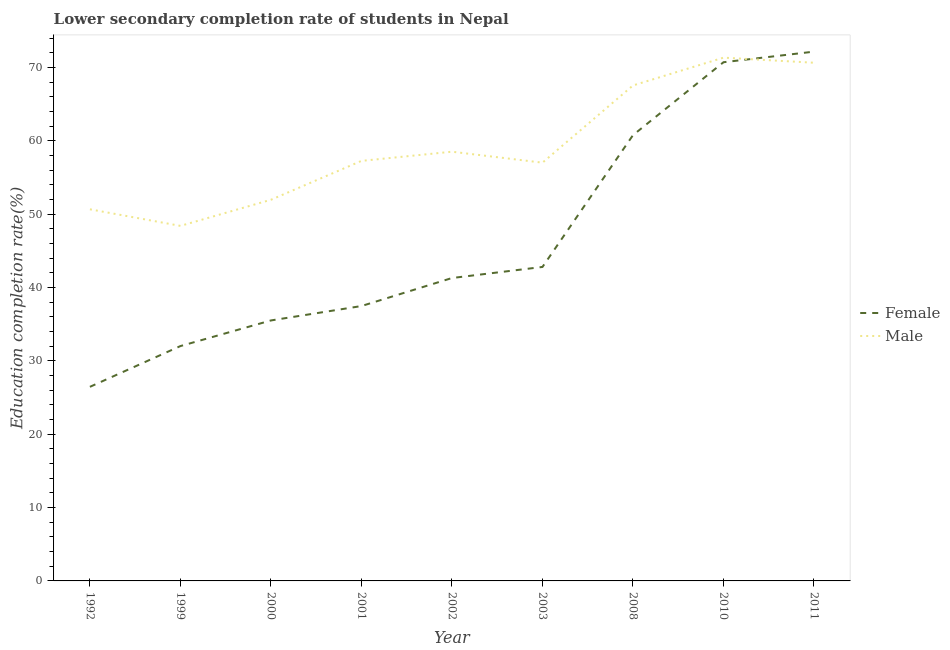Does the line corresponding to education completion rate of male students intersect with the line corresponding to education completion rate of female students?
Give a very brief answer. Yes. What is the education completion rate of female students in 1992?
Keep it short and to the point. 26.46. Across all years, what is the maximum education completion rate of female students?
Make the answer very short. 72.17. Across all years, what is the minimum education completion rate of female students?
Your response must be concise. 26.46. What is the total education completion rate of female students in the graph?
Your answer should be compact. 419.26. What is the difference between the education completion rate of male students in 1992 and that in 2010?
Give a very brief answer. -20.68. What is the difference between the education completion rate of male students in 2003 and the education completion rate of female students in 2002?
Make the answer very short. 15.73. What is the average education completion rate of female students per year?
Offer a very short reply. 46.58. In the year 2000, what is the difference between the education completion rate of female students and education completion rate of male students?
Your answer should be very brief. -16.45. What is the ratio of the education completion rate of male students in 2001 to that in 2011?
Your response must be concise. 0.81. Is the difference between the education completion rate of female students in 1999 and 2002 greater than the difference between the education completion rate of male students in 1999 and 2002?
Ensure brevity in your answer.  Yes. What is the difference between the highest and the second highest education completion rate of male students?
Your answer should be very brief. 0.69. What is the difference between the highest and the lowest education completion rate of male students?
Provide a succinct answer. 22.94. Is the sum of the education completion rate of female students in 2008 and 2011 greater than the maximum education completion rate of male students across all years?
Provide a succinct answer. Yes. Is the education completion rate of male students strictly less than the education completion rate of female students over the years?
Make the answer very short. No. Are the values on the major ticks of Y-axis written in scientific E-notation?
Your answer should be compact. No. Does the graph contain grids?
Give a very brief answer. No. Where does the legend appear in the graph?
Offer a terse response. Center right. What is the title of the graph?
Your answer should be very brief. Lower secondary completion rate of students in Nepal. What is the label or title of the X-axis?
Provide a succinct answer. Year. What is the label or title of the Y-axis?
Your response must be concise. Education completion rate(%). What is the Education completion rate(%) in Female in 1992?
Provide a succinct answer. 26.46. What is the Education completion rate(%) in Male in 1992?
Make the answer very short. 50.67. What is the Education completion rate(%) in Female in 1999?
Provide a short and direct response. 32.02. What is the Education completion rate(%) of Male in 1999?
Make the answer very short. 48.41. What is the Education completion rate(%) of Female in 2000?
Your answer should be compact. 35.52. What is the Education completion rate(%) in Male in 2000?
Keep it short and to the point. 51.97. What is the Education completion rate(%) in Female in 2001?
Provide a succinct answer. 37.48. What is the Education completion rate(%) of Male in 2001?
Make the answer very short. 57.27. What is the Education completion rate(%) of Female in 2002?
Offer a very short reply. 41.3. What is the Education completion rate(%) of Male in 2002?
Offer a very short reply. 58.52. What is the Education completion rate(%) of Female in 2003?
Provide a succinct answer. 42.81. What is the Education completion rate(%) in Male in 2003?
Keep it short and to the point. 57.03. What is the Education completion rate(%) of Female in 2008?
Provide a short and direct response. 60.78. What is the Education completion rate(%) of Male in 2008?
Offer a terse response. 67.56. What is the Education completion rate(%) in Female in 2010?
Provide a short and direct response. 70.72. What is the Education completion rate(%) in Male in 2010?
Provide a succinct answer. 71.35. What is the Education completion rate(%) in Female in 2011?
Keep it short and to the point. 72.17. What is the Education completion rate(%) in Male in 2011?
Keep it short and to the point. 70.65. Across all years, what is the maximum Education completion rate(%) in Female?
Keep it short and to the point. 72.17. Across all years, what is the maximum Education completion rate(%) in Male?
Your answer should be compact. 71.35. Across all years, what is the minimum Education completion rate(%) in Female?
Provide a succinct answer. 26.46. Across all years, what is the minimum Education completion rate(%) of Male?
Offer a terse response. 48.41. What is the total Education completion rate(%) in Female in the graph?
Offer a very short reply. 419.26. What is the total Education completion rate(%) of Male in the graph?
Offer a very short reply. 533.43. What is the difference between the Education completion rate(%) in Female in 1992 and that in 1999?
Give a very brief answer. -5.56. What is the difference between the Education completion rate(%) in Male in 1992 and that in 1999?
Your answer should be very brief. 2.26. What is the difference between the Education completion rate(%) in Female in 1992 and that in 2000?
Make the answer very short. -9.05. What is the difference between the Education completion rate(%) of Female in 1992 and that in 2001?
Offer a very short reply. -11.02. What is the difference between the Education completion rate(%) of Male in 1992 and that in 2001?
Ensure brevity in your answer.  -6.6. What is the difference between the Education completion rate(%) of Female in 1992 and that in 2002?
Your response must be concise. -14.84. What is the difference between the Education completion rate(%) of Male in 1992 and that in 2002?
Provide a succinct answer. -7.85. What is the difference between the Education completion rate(%) in Female in 1992 and that in 2003?
Your answer should be compact. -16.35. What is the difference between the Education completion rate(%) of Male in 1992 and that in 2003?
Your response must be concise. -6.36. What is the difference between the Education completion rate(%) of Female in 1992 and that in 2008?
Make the answer very short. -34.32. What is the difference between the Education completion rate(%) in Male in 1992 and that in 2008?
Make the answer very short. -16.89. What is the difference between the Education completion rate(%) in Female in 1992 and that in 2010?
Your answer should be compact. -44.26. What is the difference between the Education completion rate(%) in Male in 1992 and that in 2010?
Your response must be concise. -20.68. What is the difference between the Education completion rate(%) of Female in 1992 and that in 2011?
Provide a succinct answer. -45.7. What is the difference between the Education completion rate(%) in Male in 1992 and that in 2011?
Your answer should be very brief. -19.98. What is the difference between the Education completion rate(%) in Female in 1999 and that in 2000?
Give a very brief answer. -3.49. What is the difference between the Education completion rate(%) of Male in 1999 and that in 2000?
Your answer should be very brief. -3.56. What is the difference between the Education completion rate(%) of Female in 1999 and that in 2001?
Provide a succinct answer. -5.46. What is the difference between the Education completion rate(%) of Male in 1999 and that in 2001?
Keep it short and to the point. -8.86. What is the difference between the Education completion rate(%) in Female in 1999 and that in 2002?
Offer a very short reply. -9.28. What is the difference between the Education completion rate(%) of Male in 1999 and that in 2002?
Your response must be concise. -10.11. What is the difference between the Education completion rate(%) in Female in 1999 and that in 2003?
Offer a terse response. -10.79. What is the difference between the Education completion rate(%) of Male in 1999 and that in 2003?
Provide a short and direct response. -8.62. What is the difference between the Education completion rate(%) of Female in 1999 and that in 2008?
Ensure brevity in your answer.  -28.76. What is the difference between the Education completion rate(%) in Male in 1999 and that in 2008?
Your answer should be compact. -19.15. What is the difference between the Education completion rate(%) of Female in 1999 and that in 2010?
Keep it short and to the point. -38.7. What is the difference between the Education completion rate(%) in Male in 1999 and that in 2010?
Provide a short and direct response. -22.94. What is the difference between the Education completion rate(%) in Female in 1999 and that in 2011?
Make the answer very short. -40.15. What is the difference between the Education completion rate(%) in Male in 1999 and that in 2011?
Make the answer very short. -22.24. What is the difference between the Education completion rate(%) in Female in 2000 and that in 2001?
Your answer should be very brief. -1.96. What is the difference between the Education completion rate(%) in Male in 2000 and that in 2001?
Keep it short and to the point. -5.3. What is the difference between the Education completion rate(%) of Female in 2000 and that in 2002?
Ensure brevity in your answer.  -5.78. What is the difference between the Education completion rate(%) of Male in 2000 and that in 2002?
Provide a succinct answer. -6.55. What is the difference between the Education completion rate(%) in Female in 2000 and that in 2003?
Keep it short and to the point. -7.29. What is the difference between the Education completion rate(%) in Male in 2000 and that in 2003?
Give a very brief answer. -5.06. What is the difference between the Education completion rate(%) in Female in 2000 and that in 2008?
Give a very brief answer. -25.27. What is the difference between the Education completion rate(%) of Male in 2000 and that in 2008?
Your answer should be compact. -15.59. What is the difference between the Education completion rate(%) in Female in 2000 and that in 2010?
Offer a terse response. -35.21. What is the difference between the Education completion rate(%) in Male in 2000 and that in 2010?
Your answer should be compact. -19.38. What is the difference between the Education completion rate(%) in Female in 2000 and that in 2011?
Your answer should be very brief. -36.65. What is the difference between the Education completion rate(%) of Male in 2000 and that in 2011?
Keep it short and to the point. -18.68. What is the difference between the Education completion rate(%) in Female in 2001 and that in 2002?
Offer a very short reply. -3.82. What is the difference between the Education completion rate(%) of Male in 2001 and that in 2002?
Your response must be concise. -1.25. What is the difference between the Education completion rate(%) of Female in 2001 and that in 2003?
Offer a very short reply. -5.33. What is the difference between the Education completion rate(%) in Male in 2001 and that in 2003?
Provide a short and direct response. 0.24. What is the difference between the Education completion rate(%) of Female in 2001 and that in 2008?
Provide a short and direct response. -23.3. What is the difference between the Education completion rate(%) in Male in 2001 and that in 2008?
Offer a terse response. -10.29. What is the difference between the Education completion rate(%) in Female in 2001 and that in 2010?
Make the answer very short. -33.24. What is the difference between the Education completion rate(%) of Male in 2001 and that in 2010?
Make the answer very short. -14.08. What is the difference between the Education completion rate(%) of Female in 2001 and that in 2011?
Make the answer very short. -34.69. What is the difference between the Education completion rate(%) of Male in 2001 and that in 2011?
Ensure brevity in your answer.  -13.38. What is the difference between the Education completion rate(%) of Female in 2002 and that in 2003?
Your answer should be compact. -1.51. What is the difference between the Education completion rate(%) in Male in 2002 and that in 2003?
Give a very brief answer. 1.5. What is the difference between the Education completion rate(%) in Female in 2002 and that in 2008?
Offer a terse response. -19.48. What is the difference between the Education completion rate(%) of Male in 2002 and that in 2008?
Your answer should be compact. -9.03. What is the difference between the Education completion rate(%) in Female in 2002 and that in 2010?
Ensure brevity in your answer.  -29.42. What is the difference between the Education completion rate(%) of Male in 2002 and that in 2010?
Provide a succinct answer. -12.82. What is the difference between the Education completion rate(%) of Female in 2002 and that in 2011?
Give a very brief answer. -30.87. What is the difference between the Education completion rate(%) of Male in 2002 and that in 2011?
Your answer should be compact. -12.13. What is the difference between the Education completion rate(%) of Female in 2003 and that in 2008?
Make the answer very short. -17.97. What is the difference between the Education completion rate(%) in Male in 2003 and that in 2008?
Make the answer very short. -10.53. What is the difference between the Education completion rate(%) in Female in 2003 and that in 2010?
Give a very brief answer. -27.91. What is the difference between the Education completion rate(%) of Male in 2003 and that in 2010?
Provide a succinct answer. -14.32. What is the difference between the Education completion rate(%) of Female in 2003 and that in 2011?
Provide a short and direct response. -29.36. What is the difference between the Education completion rate(%) in Male in 2003 and that in 2011?
Give a very brief answer. -13.63. What is the difference between the Education completion rate(%) of Female in 2008 and that in 2010?
Give a very brief answer. -9.94. What is the difference between the Education completion rate(%) of Male in 2008 and that in 2010?
Make the answer very short. -3.79. What is the difference between the Education completion rate(%) in Female in 2008 and that in 2011?
Make the answer very short. -11.39. What is the difference between the Education completion rate(%) in Male in 2008 and that in 2011?
Make the answer very short. -3.1. What is the difference between the Education completion rate(%) in Female in 2010 and that in 2011?
Provide a short and direct response. -1.44. What is the difference between the Education completion rate(%) in Male in 2010 and that in 2011?
Your response must be concise. 0.69. What is the difference between the Education completion rate(%) in Female in 1992 and the Education completion rate(%) in Male in 1999?
Provide a short and direct response. -21.95. What is the difference between the Education completion rate(%) of Female in 1992 and the Education completion rate(%) of Male in 2000?
Ensure brevity in your answer.  -25.51. What is the difference between the Education completion rate(%) of Female in 1992 and the Education completion rate(%) of Male in 2001?
Provide a short and direct response. -30.81. What is the difference between the Education completion rate(%) in Female in 1992 and the Education completion rate(%) in Male in 2002?
Ensure brevity in your answer.  -32.06. What is the difference between the Education completion rate(%) in Female in 1992 and the Education completion rate(%) in Male in 2003?
Your response must be concise. -30.56. What is the difference between the Education completion rate(%) of Female in 1992 and the Education completion rate(%) of Male in 2008?
Make the answer very short. -41.09. What is the difference between the Education completion rate(%) of Female in 1992 and the Education completion rate(%) of Male in 2010?
Offer a terse response. -44.88. What is the difference between the Education completion rate(%) of Female in 1992 and the Education completion rate(%) of Male in 2011?
Offer a terse response. -44.19. What is the difference between the Education completion rate(%) in Female in 1999 and the Education completion rate(%) in Male in 2000?
Give a very brief answer. -19.95. What is the difference between the Education completion rate(%) in Female in 1999 and the Education completion rate(%) in Male in 2001?
Your answer should be compact. -25.25. What is the difference between the Education completion rate(%) of Female in 1999 and the Education completion rate(%) of Male in 2002?
Ensure brevity in your answer.  -26.5. What is the difference between the Education completion rate(%) in Female in 1999 and the Education completion rate(%) in Male in 2003?
Ensure brevity in your answer.  -25.01. What is the difference between the Education completion rate(%) in Female in 1999 and the Education completion rate(%) in Male in 2008?
Keep it short and to the point. -35.53. What is the difference between the Education completion rate(%) of Female in 1999 and the Education completion rate(%) of Male in 2010?
Offer a very short reply. -39.32. What is the difference between the Education completion rate(%) in Female in 1999 and the Education completion rate(%) in Male in 2011?
Your answer should be very brief. -38.63. What is the difference between the Education completion rate(%) of Female in 2000 and the Education completion rate(%) of Male in 2001?
Provide a succinct answer. -21.76. What is the difference between the Education completion rate(%) of Female in 2000 and the Education completion rate(%) of Male in 2002?
Offer a terse response. -23.01. What is the difference between the Education completion rate(%) in Female in 2000 and the Education completion rate(%) in Male in 2003?
Your answer should be very brief. -21.51. What is the difference between the Education completion rate(%) of Female in 2000 and the Education completion rate(%) of Male in 2008?
Make the answer very short. -32.04. What is the difference between the Education completion rate(%) in Female in 2000 and the Education completion rate(%) in Male in 2010?
Provide a succinct answer. -35.83. What is the difference between the Education completion rate(%) of Female in 2000 and the Education completion rate(%) of Male in 2011?
Keep it short and to the point. -35.14. What is the difference between the Education completion rate(%) of Female in 2001 and the Education completion rate(%) of Male in 2002?
Your answer should be compact. -21.04. What is the difference between the Education completion rate(%) of Female in 2001 and the Education completion rate(%) of Male in 2003?
Offer a terse response. -19.55. What is the difference between the Education completion rate(%) in Female in 2001 and the Education completion rate(%) in Male in 2008?
Provide a succinct answer. -30.08. What is the difference between the Education completion rate(%) in Female in 2001 and the Education completion rate(%) in Male in 2010?
Ensure brevity in your answer.  -33.87. What is the difference between the Education completion rate(%) of Female in 2001 and the Education completion rate(%) of Male in 2011?
Provide a short and direct response. -33.17. What is the difference between the Education completion rate(%) of Female in 2002 and the Education completion rate(%) of Male in 2003?
Offer a terse response. -15.73. What is the difference between the Education completion rate(%) of Female in 2002 and the Education completion rate(%) of Male in 2008?
Your answer should be very brief. -26.26. What is the difference between the Education completion rate(%) of Female in 2002 and the Education completion rate(%) of Male in 2010?
Give a very brief answer. -30.05. What is the difference between the Education completion rate(%) in Female in 2002 and the Education completion rate(%) in Male in 2011?
Your answer should be very brief. -29.35. What is the difference between the Education completion rate(%) of Female in 2003 and the Education completion rate(%) of Male in 2008?
Your response must be concise. -24.75. What is the difference between the Education completion rate(%) in Female in 2003 and the Education completion rate(%) in Male in 2010?
Offer a very short reply. -28.54. What is the difference between the Education completion rate(%) of Female in 2003 and the Education completion rate(%) of Male in 2011?
Offer a very short reply. -27.84. What is the difference between the Education completion rate(%) in Female in 2008 and the Education completion rate(%) in Male in 2010?
Ensure brevity in your answer.  -10.57. What is the difference between the Education completion rate(%) of Female in 2008 and the Education completion rate(%) of Male in 2011?
Your answer should be very brief. -9.87. What is the difference between the Education completion rate(%) of Female in 2010 and the Education completion rate(%) of Male in 2011?
Make the answer very short. 0.07. What is the average Education completion rate(%) of Female per year?
Give a very brief answer. 46.58. What is the average Education completion rate(%) of Male per year?
Your answer should be compact. 59.27. In the year 1992, what is the difference between the Education completion rate(%) of Female and Education completion rate(%) of Male?
Your response must be concise. -24.21. In the year 1999, what is the difference between the Education completion rate(%) in Female and Education completion rate(%) in Male?
Provide a short and direct response. -16.39. In the year 2000, what is the difference between the Education completion rate(%) of Female and Education completion rate(%) of Male?
Your response must be concise. -16.45. In the year 2001, what is the difference between the Education completion rate(%) of Female and Education completion rate(%) of Male?
Your response must be concise. -19.79. In the year 2002, what is the difference between the Education completion rate(%) of Female and Education completion rate(%) of Male?
Provide a succinct answer. -17.22. In the year 2003, what is the difference between the Education completion rate(%) in Female and Education completion rate(%) in Male?
Provide a succinct answer. -14.22. In the year 2008, what is the difference between the Education completion rate(%) of Female and Education completion rate(%) of Male?
Provide a short and direct response. -6.78. In the year 2010, what is the difference between the Education completion rate(%) of Female and Education completion rate(%) of Male?
Your answer should be compact. -0.62. In the year 2011, what is the difference between the Education completion rate(%) in Female and Education completion rate(%) in Male?
Make the answer very short. 1.51. What is the ratio of the Education completion rate(%) in Female in 1992 to that in 1999?
Your answer should be compact. 0.83. What is the ratio of the Education completion rate(%) in Male in 1992 to that in 1999?
Your response must be concise. 1.05. What is the ratio of the Education completion rate(%) of Female in 1992 to that in 2000?
Keep it short and to the point. 0.75. What is the ratio of the Education completion rate(%) in Male in 1992 to that in 2000?
Give a very brief answer. 0.97. What is the ratio of the Education completion rate(%) of Female in 1992 to that in 2001?
Make the answer very short. 0.71. What is the ratio of the Education completion rate(%) of Male in 1992 to that in 2001?
Offer a terse response. 0.88. What is the ratio of the Education completion rate(%) in Female in 1992 to that in 2002?
Provide a short and direct response. 0.64. What is the ratio of the Education completion rate(%) of Male in 1992 to that in 2002?
Your answer should be very brief. 0.87. What is the ratio of the Education completion rate(%) in Female in 1992 to that in 2003?
Provide a succinct answer. 0.62. What is the ratio of the Education completion rate(%) of Male in 1992 to that in 2003?
Provide a short and direct response. 0.89. What is the ratio of the Education completion rate(%) of Female in 1992 to that in 2008?
Give a very brief answer. 0.44. What is the ratio of the Education completion rate(%) in Female in 1992 to that in 2010?
Give a very brief answer. 0.37. What is the ratio of the Education completion rate(%) in Male in 1992 to that in 2010?
Keep it short and to the point. 0.71. What is the ratio of the Education completion rate(%) in Female in 1992 to that in 2011?
Offer a terse response. 0.37. What is the ratio of the Education completion rate(%) of Male in 1992 to that in 2011?
Ensure brevity in your answer.  0.72. What is the ratio of the Education completion rate(%) of Female in 1999 to that in 2000?
Make the answer very short. 0.9. What is the ratio of the Education completion rate(%) in Male in 1999 to that in 2000?
Offer a terse response. 0.93. What is the ratio of the Education completion rate(%) in Female in 1999 to that in 2001?
Your answer should be very brief. 0.85. What is the ratio of the Education completion rate(%) in Male in 1999 to that in 2001?
Offer a very short reply. 0.85. What is the ratio of the Education completion rate(%) of Female in 1999 to that in 2002?
Provide a succinct answer. 0.78. What is the ratio of the Education completion rate(%) in Male in 1999 to that in 2002?
Your answer should be very brief. 0.83. What is the ratio of the Education completion rate(%) in Female in 1999 to that in 2003?
Provide a short and direct response. 0.75. What is the ratio of the Education completion rate(%) in Male in 1999 to that in 2003?
Offer a very short reply. 0.85. What is the ratio of the Education completion rate(%) in Female in 1999 to that in 2008?
Provide a succinct answer. 0.53. What is the ratio of the Education completion rate(%) in Male in 1999 to that in 2008?
Your answer should be very brief. 0.72. What is the ratio of the Education completion rate(%) of Female in 1999 to that in 2010?
Offer a very short reply. 0.45. What is the ratio of the Education completion rate(%) of Male in 1999 to that in 2010?
Make the answer very short. 0.68. What is the ratio of the Education completion rate(%) of Female in 1999 to that in 2011?
Provide a short and direct response. 0.44. What is the ratio of the Education completion rate(%) of Male in 1999 to that in 2011?
Make the answer very short. 0.69. What is the ratio of the Education completion rate(%) of Female in 2000 to that in 2001?
Your answer should be compact. 0.95. What is the ratio of the Education completion rate(%) in Male in 2000 to that in 2001?
Offer a very short reply. 0.91. What is the ratio of the Education completion rate(%) in Female in 2000 to that in 2002?
Your answer should be compact. 0.86. What is the ratio of the Education completion rate(%) of Male in 2000 to that in 2002?
Your response must be concise. 0.89. What is the ratio of the Education completion rate(%) in Female in 2000 to that in 2003?
Your answer should be compact. 0.83. What is the ratio of the Education completion rate(%) in Male in 2000 to that in 2003?
Offer a terse response. 0.91. What is the ratio of the Education completion rate(%) in Female in 2000 to that in 2008?
Give a very brief answer. 0.58. What is the ratio of the Education completion rate(%) of Male in 2000 to that in 2008?
Make the answer very short. 0.77. What is the ratio of the Education completion rate(%) of Female in 2000 to that in 2010?
Your answer should be very brief. 0.5. What is the ratio of the Education completion rate(%) in Male in 2000 to that in 2010?
Your answer should be compact. 0.73. What is the ratio of the Education completion rate(%) in Female in 2000 to that in 2011?
Provide a short and direct response. 0.49. What is the ratio of the Education completion rate(%) of Male in 2000 to that in 2011?
Your answer should be very brief. 0.74. What is the ratio of the Education completion rate(%) in Female in 2001 to that in 2002?
Provide a succinct answer. 0.91. What is the ratio of the Education completion rate(%) of Male in 2001 to that in 2002?
Provide a short and direct response. 0.98. What is the ratio of the Education completion rate(%) of Female in 2001 to that in 2003?
Your answer should be compact. 0.88. What is the ratio of the Education completion rate(%) of Male in 2001 to that in 2003?
Keep it short and to the point. 1. What is the ratio of the Education completion rate(%) of Female in 2001 to that in 2008?
Ensure brevity in your answer.  0.62. What is the ratio of the Education completion rate(%) in Male in 2001 to that in 2008?
Offer a very short reply. 0.85. What is the ratio of the Education completion rate(%) in Female in 2001 to that in 2010?
Your response must be concise. 0.53. What is the ratio of the Education completion rate(%) of Male in 2001 to that in 2010?
Your answer should be compact. 0.8. What is the ratio of the Education completion rate(%) in Female in 2001 to that in 2011?
Give a very brief answer. 0.52. What is the ratio of the Education completion rate(%) of Male in 2001 to that in 2011?
Ensure brevity in your answer.  0.81. What is the ratio of the Education completion rate(%) in Female in 2002 to that in 2003?
Your answer should be compact. 0.96. What is the ratio of the Education completion rate(%) in Male in 2002 to that in 2003?
Ensure brevity in your answer.  1.03. What is the ratio of the Education completion rate(%) of Female in 2002 to that in 2008?
Provide a short and direct response. 0.68. What is the ratio of the Education completion rate(%) in Male in 2002 to that in 2008?
Offer a terse response. 0.87. What is the ratio of the Education completion rate(%) in Female in 2002 to that in 2010?
Your response must be concise. 0.58. What is the ratio of the Education completion rate(%) in Male in 2002 to that in 2010?
Your answer should be compact. 0.82. What is the ratio of the Education completion rate(%) of Female in 2002 to that in 2011?
Offer a terse response. 0.57. What is the ratio of the Education completion rate(%) in Male in 2002 to that in 2011?
Provide a short and direct response. 0.83. What is the ratio of the Education completion rate(%) in Female in 2003 to that in 2008?
Provide a short and direct response. 0.7. What is the ratio of the Education completion rate(%) of Male in 2003 to that in 2008?
Your answer should be compact. 0.84. What is the ratio of the Education completion rate(%) of Female in 2003 to that in 2010?
Give a very brief answer. 0.61. What is the ratio of the Education completion rate(%) in Male in 2003 to that in 2010?
Keep it short and to the point. 0.8. What is the ratio of the Education completion rate(%) of Female in 2003 to that in 2011?
Give a very brief answer. 0.59. What is the ratio of the Education completion rate(%) in Male in 2003 to that in 2011?
Provide a short and direct response. 0.81. What is the ratio of the Education completion rate(%) of Female in 2008 to that in 2010?
Your response must be concise. 0.86. What is the ratio of the Education completion rate(%) of Male in 2008 to that in 2010?
Provide a short and direct response. 0.95. What is the ratio of the Education completion rate(%) in Female in 2008 to that in 2011?
Give a very brief answer. 0.84. What is the ratio of the Education completion rate(%) of Male in 2008 to that in 2011?
Provide a short and direct response. 0.96. What is the ratio of the Education completion rate(%) of Male in 2010 to that in 2011?
Your answer should be compact. 1.01. What is the difference between the highest and the second highest Education completion rate(%) of Female?
Keep it short and to the point. 1.44. What is the difference between the highest and the second highest Education completion rate(%) in Male?
Provide a succinct answer. 0.69. What is the difference between the highest and the lowest Education completion rate(%) in Female?
Your response must be concise. 45.7. What is the difference between the highest and the lowest Education completion rate(%) of Male?
Provide a short and direct response. 22.94. 